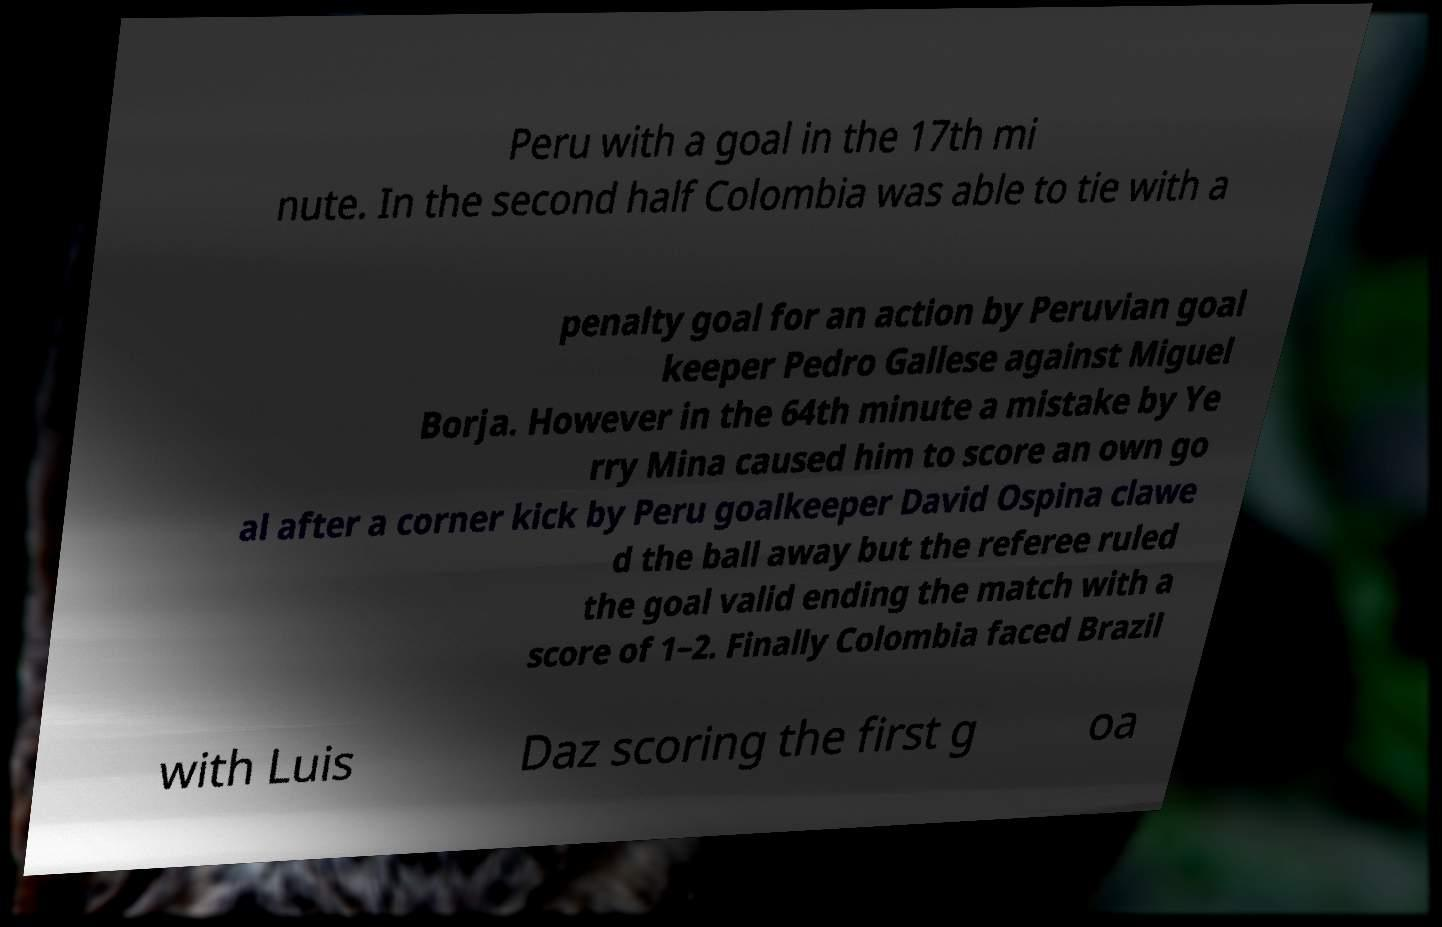Can you accurately transcribe the text from the provided image for me? Peru with a goal in the 17th mi nute. In the second half Colombia was able to tie with a penalty goal for an action by Peruvian goal keeper Pedro Gallese against Miguel Borja. However in the 64th minute a mistake by Ye rry Mina caused him to score an own go al after a corner kick by Peru goalkeeper David Ospina clawe d the ball away but the referee ruled the goal valid ending the match with a score of 1–2. Finally Colombia faced Brazil with Luis Daz scoring the first g oa 